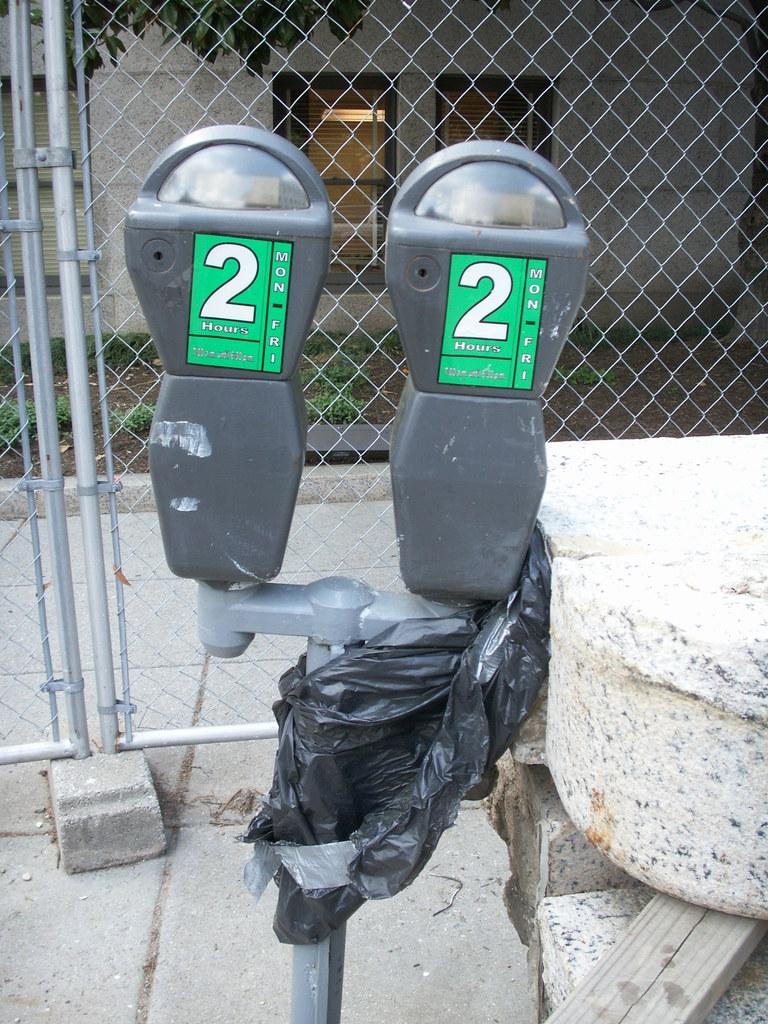Is there a 2 on there because there are two terminals?
Keep it short and to the point. Unanswerable. What number is on these terminals?
Make the answer very short. 2. 